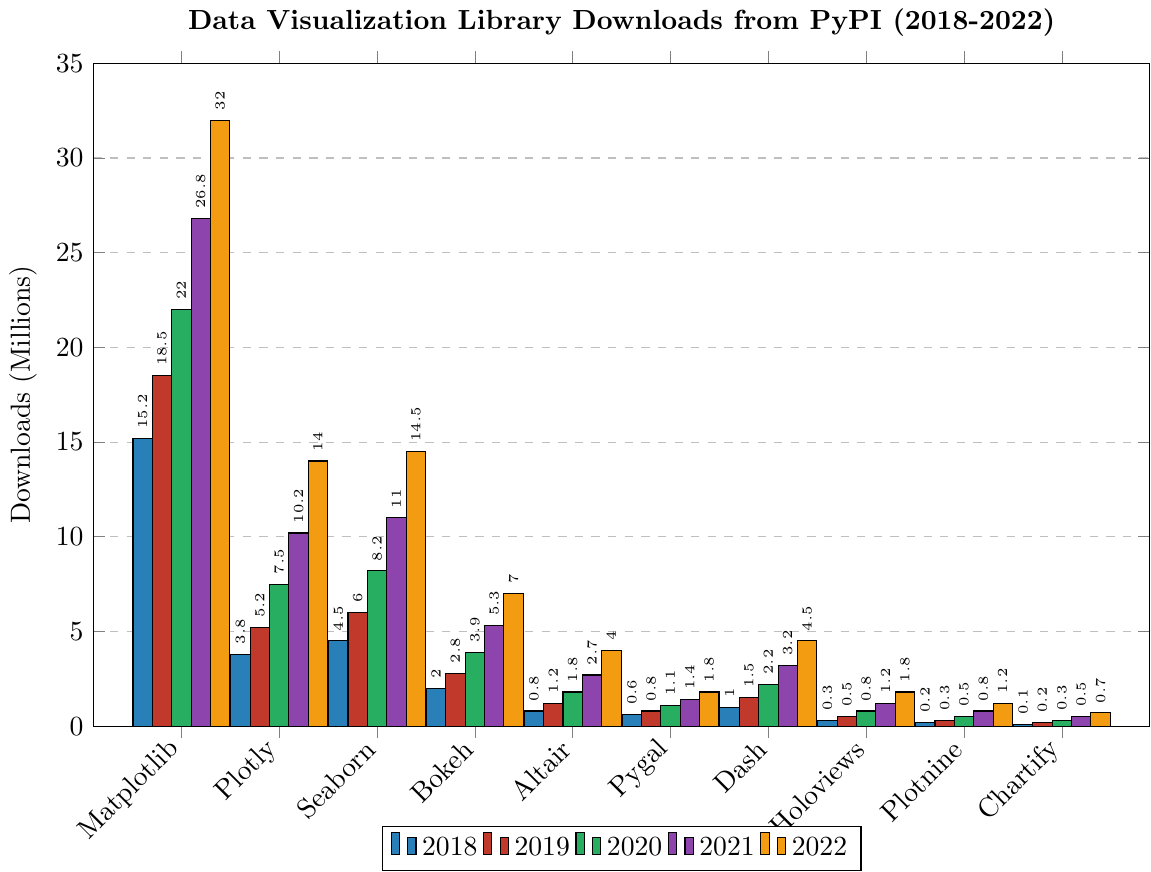Which library had the highest number of downloads in 2022? To find the library with the highest downloads in 2022, locate the tallest bar for the 2022 data. Matplotlib's bar is the tallest.
Answer: Matplotlib How did the number of downloads for Plotly change from 2018 to 2022? Compare Plotly's bars from 2018 to 2022 to observe the change. Plotly's download count increased from 3.8 million in 2018 to 14 million in 2022.
Answer: Increased What was the total number of downloads for Seaborn across all years? Add Seaborn's download numbers for each year: 4.5 + 6.0 + 8.2 + 11.0 + 14.5 = 44.2 million.
Answer: 44.2 million Which year did Dash see the most significant increase in downloads? Look for the year-to-year changes in Dash's bars. The most significant increase is from 2020 to 2021, where it jumps from 2.2 million to 3.2 million.
Answer: 2021 How many more downloads did Matplotlib have than Plotly in 2022? Subtract Plotly’s downloads from Matplotlib’s downloads in 2022: 32 million - 14 million = 18 million.
Answer: 18 million Which library had the least number of downloads in 2019 and what was the number? Identify the shortest bar in the 2019 data. Chartify had the least downloads in 2019 with 0.2 million.
Answer: Chartify, 0.2 million How did Bokeh's downloads change from 2018 to 2022? Compare the height of Bokeh's bars from 2018 to 2022. The downloads increased from 2.0 million in 2018 to 7.0 million in 2022.
Answer: Increased Which library had a download count of 0.3 million in 2019? Locate the bar for 2019 at the height corresponding to 0.3 million. Holoviews had a download count of 0.3 million in 2019.
Answer: Holoviews Rank the libraries by their 2022 download numbers from highest to lowest. Order the heights of the 2022 bars from tallest to shortest: Matplotlib, Seaborn, Plotly, Bokeh, Altair, Dash, Pygal, Holoviews, Plotnine, Chartify.
Answer: Matplotlib, Seaborn, Plotly, Bokeh, Altair, Dash, Pygal, Holoviews, Plotnine, Chartify 